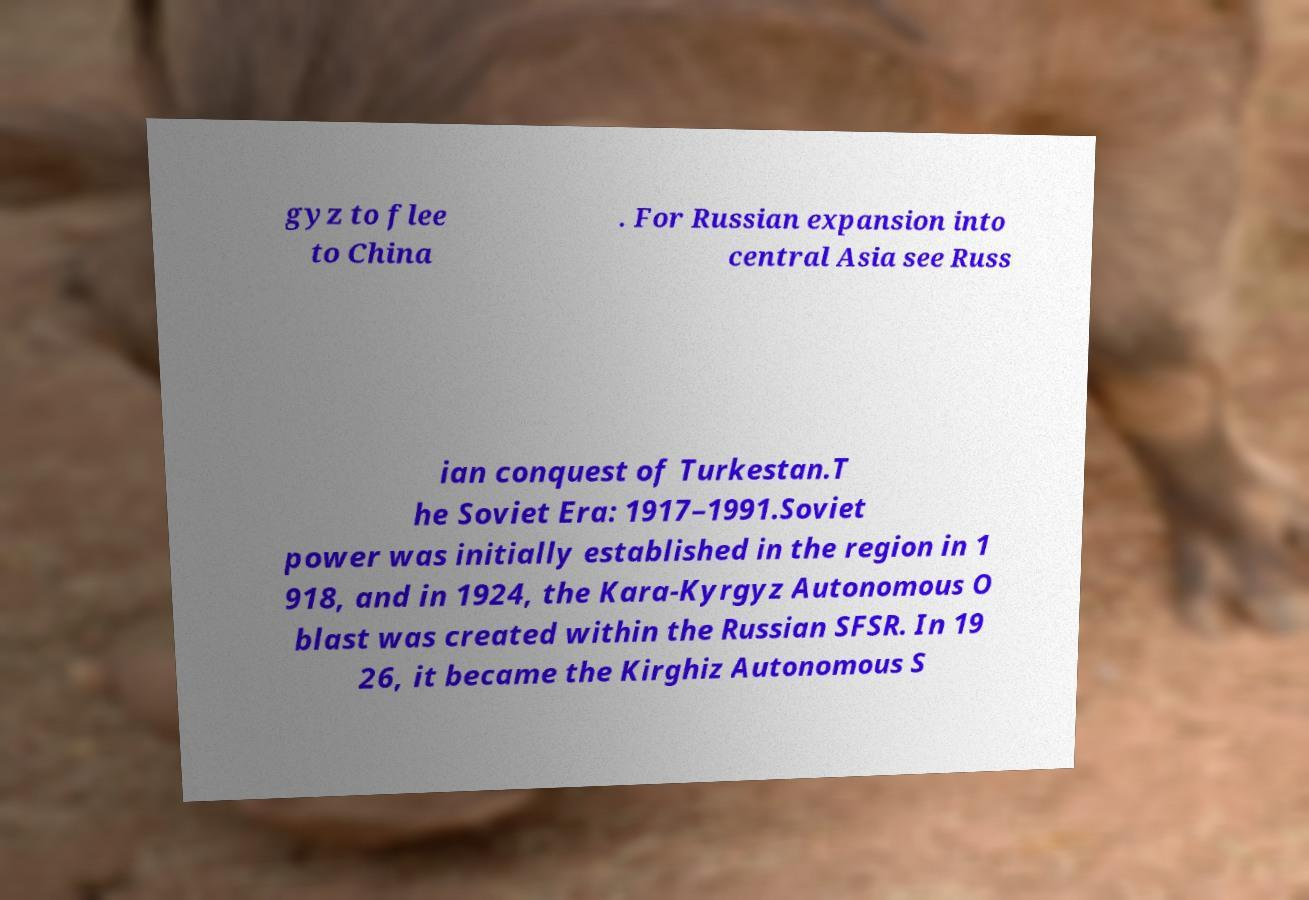Please identify and transcribe the text found in this image. gyz to flee to China . For Russian expansion into central Asia see Russ ian conquest of Turkestan.T he Soviet Era: 1917–1991.Soviet power was initially established in the region in 1 918, and in 1924, the Kara-Kyrgyz Autonomous O blast was created within the Russian SFSR. In 19 26, it became the Kirghiz Autonomous S 